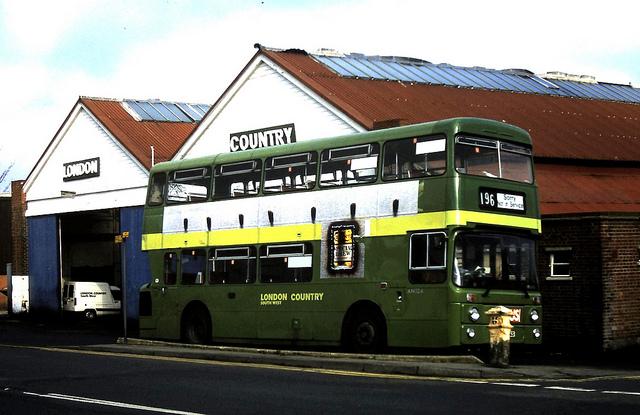Could this be in Alaska?
Give a very brief answer. No. How many buses are there here?
Be succinct. 1. What kind of bus is that?
Answer briefly. Double decker. How many skylights do you see?
Answer briefly. 2. 